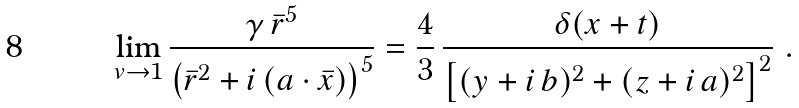Convert formula to latex. <formula><loc_0><loc_0><loc_500><loc_500>\lim _ { v \rightarrow 1 } \frac { \gamma \, \bar { r } ^ { 5 } } { \left ( \bar { r } ^ { 2 } + i \, ( { a } \cdot { \bar { x } } ) \right ) ^ { 5 } } = \frac { 4 } { 3 } \, \frac { \delta ( x + t ) } { \left [ ( y + i \, b ) ^ { 2 } + ( z + i \, a ) ^ { 2 } \right ] ^ { 2 } } \ .</formula> 